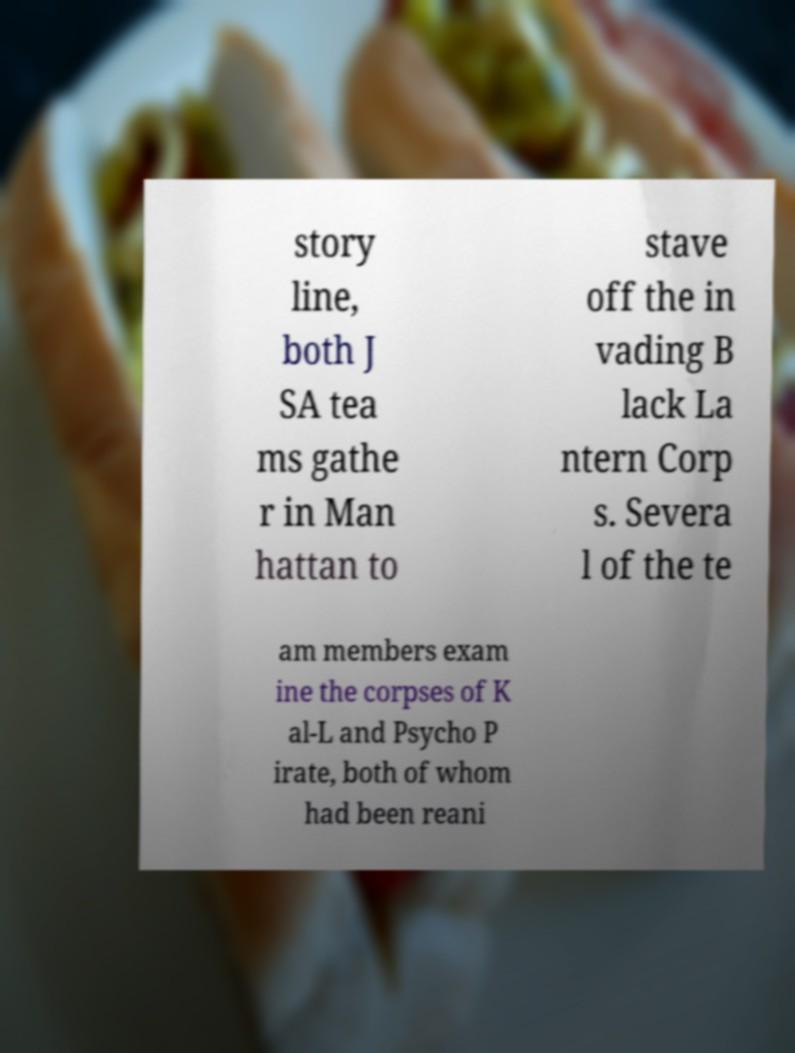Can you accurately transcribe the text from the provided image for me? story line, both J SA tea ms gathe r in Man hattan to stave off the in vading B lack La ntern Corp s. Severa l of the te am members exam ine the corpses of K al-L and Psycho P irate, both of whom had been reani 